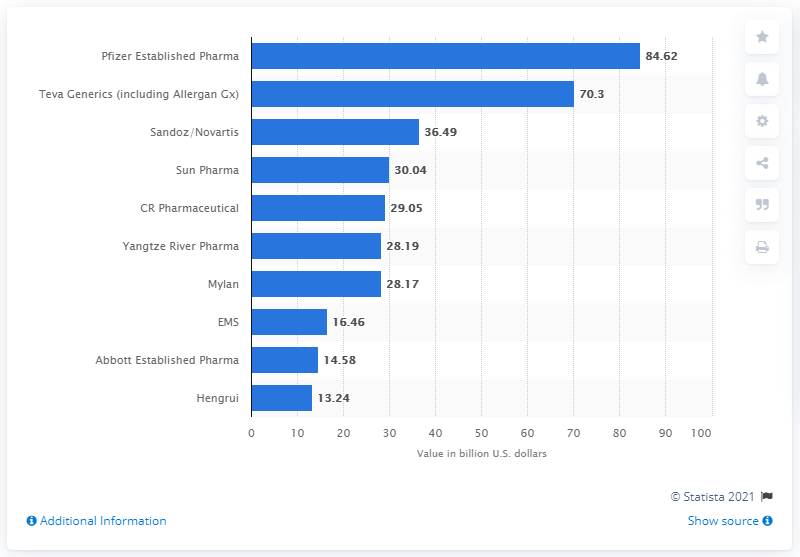Indicate a few pertinent items in this graphic. In 2016, Pfizer's Established Pharma business was valued at approximately 84.62 U.S. dollars. Hengrui was valued at 13.24. In 2016, Pfizer was the leading generic drug manufacturing company. Established Pharma was its name. 